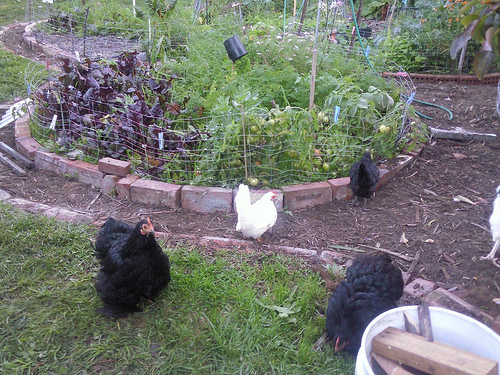<image>
Can you confirm if the pot is behind the turkey? Yes. From this viewpoint, the pot is positioned behind the turkey, with the turkey partially or fully occluding the pot. Where is the chicken in relation to the other chicken? Is it behind the other chicken? No. The chicken is not behind the other chicken. From this viewpoint, the chicken appears to be positioned elsewhere in the scene. 